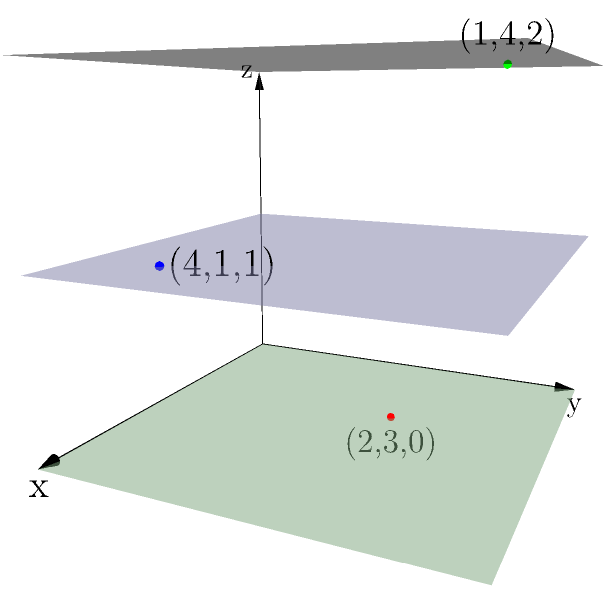In an archaeological excavation site, three artifacts have been discovered at different depths. The site is represented using a 3D coordinate system where the x and y axes represent horizontal distances (in meters) from a fixed reference point, and the z-axis represents depth (in meters) below the surface. The artifacts are located at coordinates (2,3,0), (4,1,1), and (1,4,2). What is the vertical distance (in meters) between the highest and lowest artifacts? To find the vertical distance between the highest and lowest artifacts, we need to follow these steps:

1. Identify the z-coordinates of each artifact:
   - Artifact 1: (2,3,0) → z = 0
   - Artifact 2: (4,1,1) → z = 1
   - Artifact 3: (1,4,2) → z = 2

2. Determine the highest and lowest artifacts:
   - Highest artifact: z = 0 (closest to the surface)
   - Lowest artifact: z = 2 (deepest below the surface)

3. Calculate the vertical distance:
   Vertical distance = z_lowest - z_highest
   $$ \text{Vertical distance} = 2 - 0 = 2 $$

Therefore, the vertical distance between the highest and lowest artifacts is 2 meters.
Answer: 2 meters 